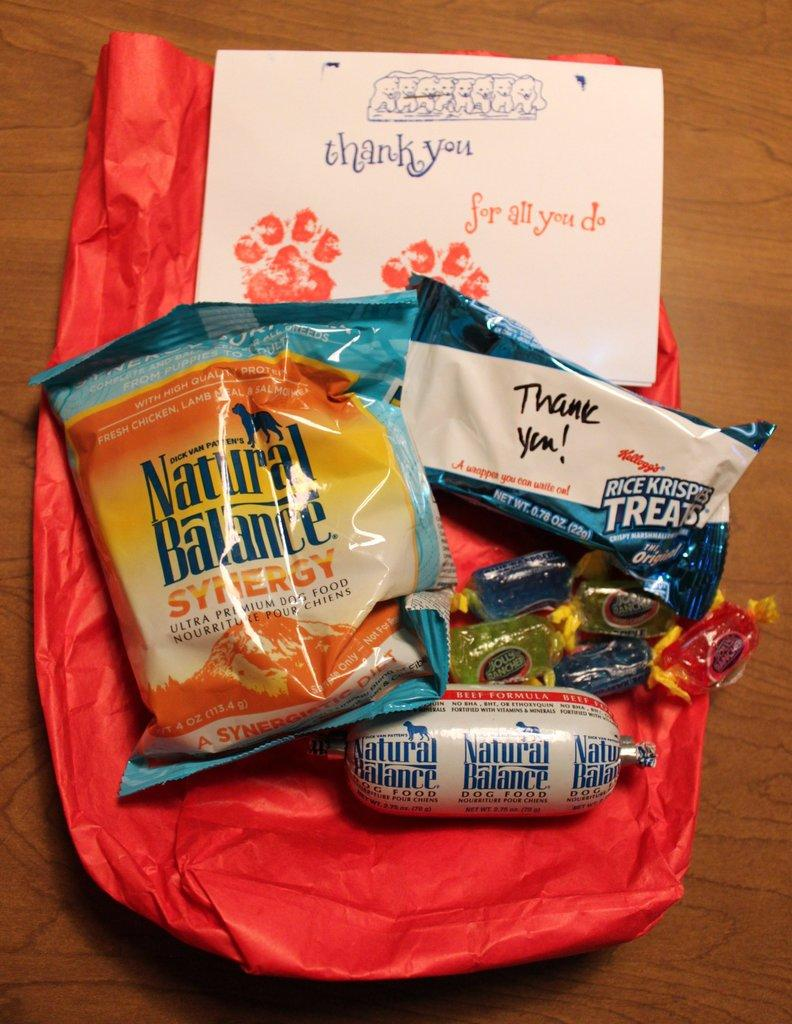What type of food items are present in the image? There are candies in the image. What else can be seen on the table besides candies? There are packets and a paper with text and design on the table. Can you describe the paper in the image? The paper has text and a design on it. What type of cushion is used to support the air in the image? There is no cushion or air present in the image; it only features candies, packets, and a paper with text and design on a table. 